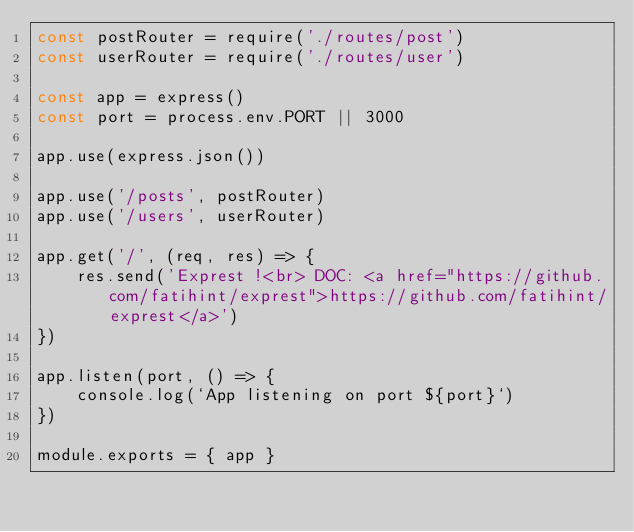<code> <loc_0><loc_0><loc_500><loc_500><_JavaScript_>const postRouter = require('./routes/post')
const userRouter = require('./routes/user')

const app = express()
const port = process.env.PORT || 3000

app.use(express.json())

app.use('/posts', postRouter)
app.use('/users', userRouter)

app.get('/', (req, res) => {
    res.send('Exprest !<br> DOC: <a href="https://github.com/fatihint/exprest">https://github.com/fatihint/exprest</a>')
})

app.listen(port, () => {
    console.log(`App listening on port ${port}`)
})

module.exports = { app }</code> 